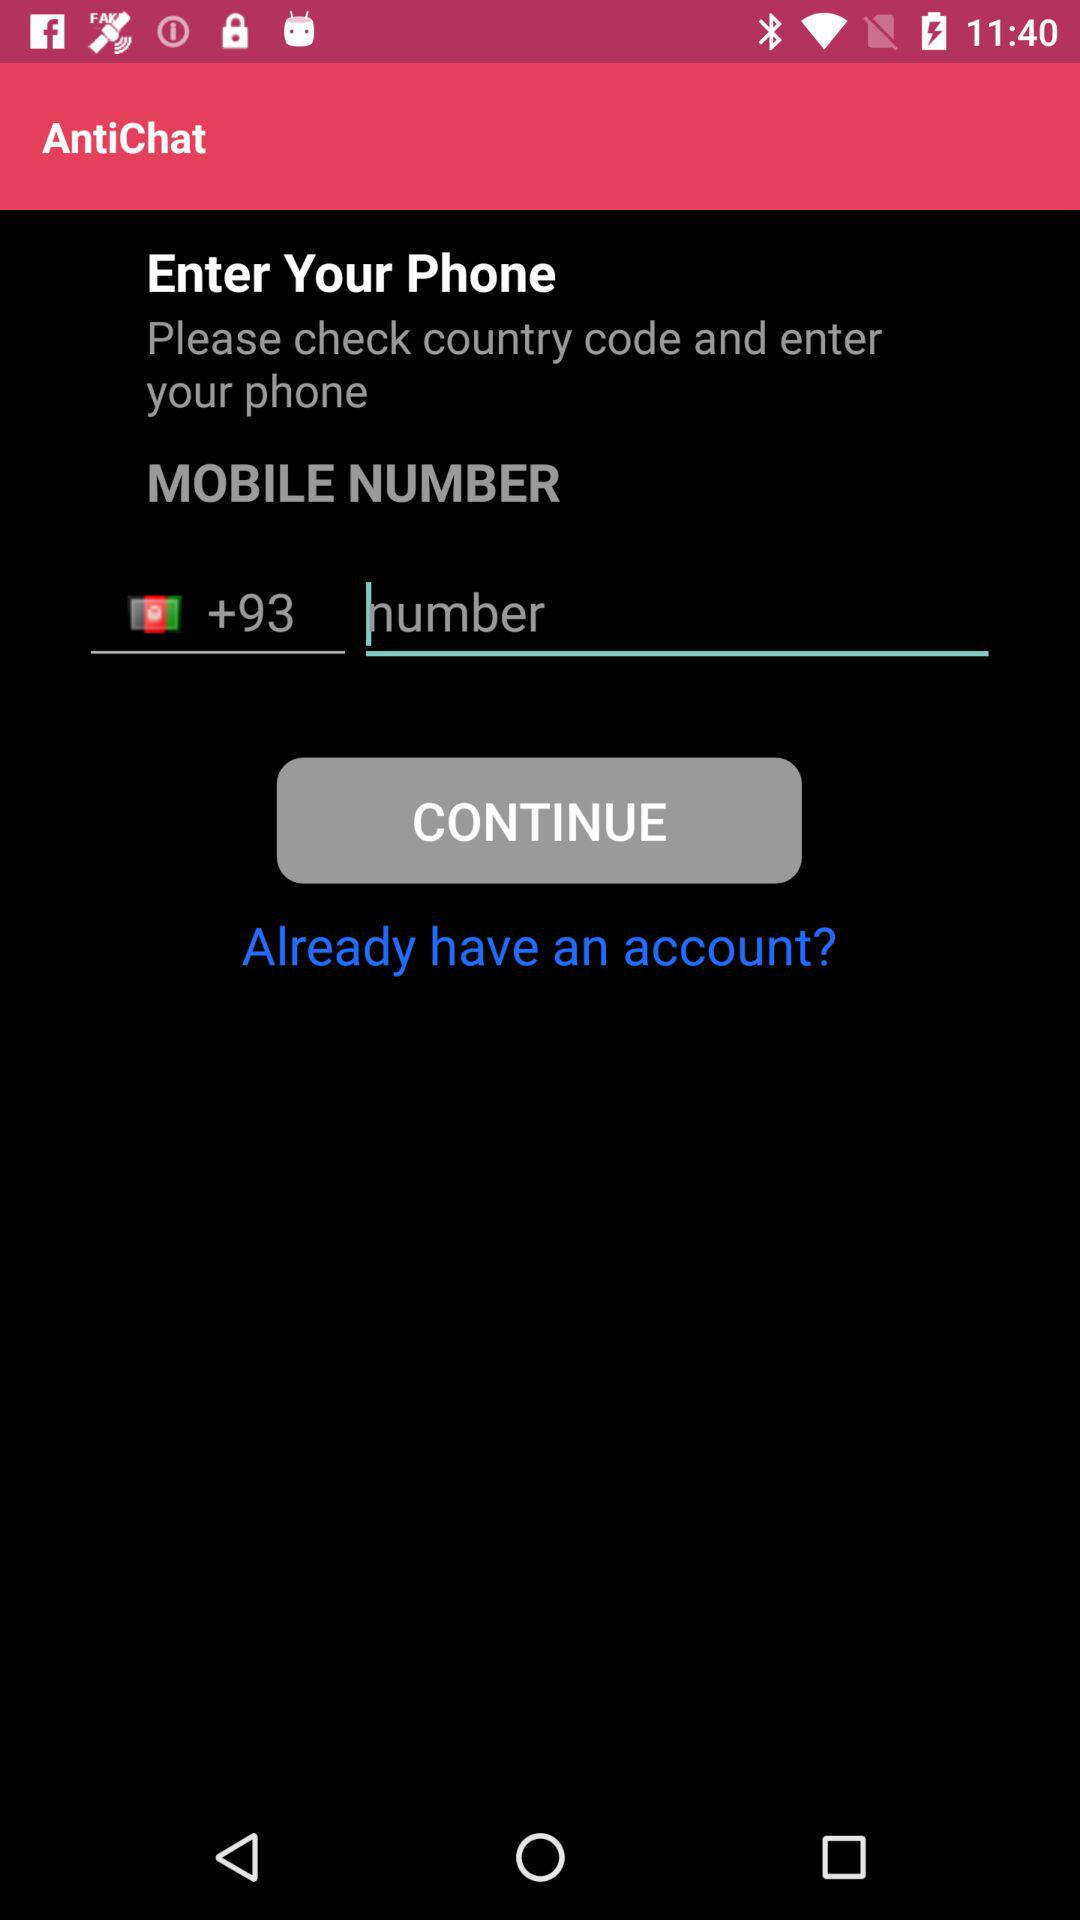What is the mentioned country code? The mentioned country code is +93. 